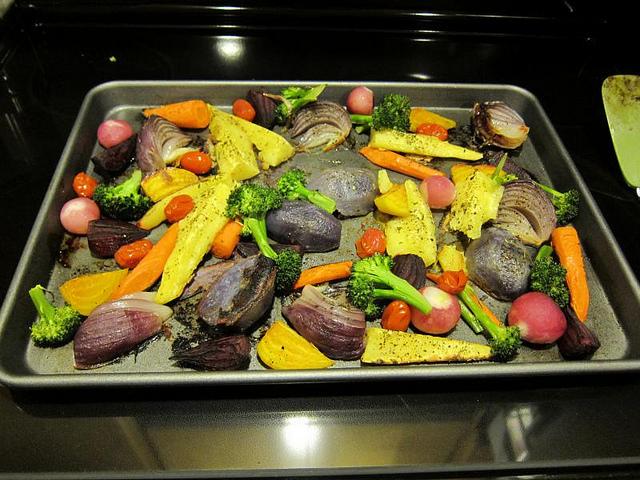Will this be cooked in an oven?
Short answer required. Yes. How many pieces of mushroom are in this mix?
Write a very short answer. 0. Is this a healthy meal?
Give a very brief answer. Yes. 